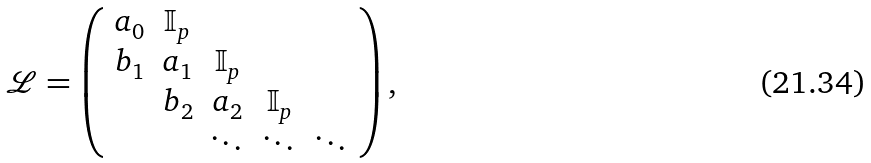<formula> <loc_0><loc_0><loc_500><loc_500>\mathcal { L } = \left ( \begin{array} { c c c c c } a _ { 0 } & \mathbb { I } _ { p } & & & \\ b _ { 1 } & a _ { 1 } & \mathbb { I } _ { p } & & \\ & b _ { 2 } & a _ { 2 } & \mathbb { I } _ { p } & \\ & & \ddots & \ddots & \ddots \end{array} \right ) ,</formula> 